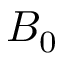<formula> <loc_0><loc_0><loc_500><loc_500>B _ { 0 }</formula> 